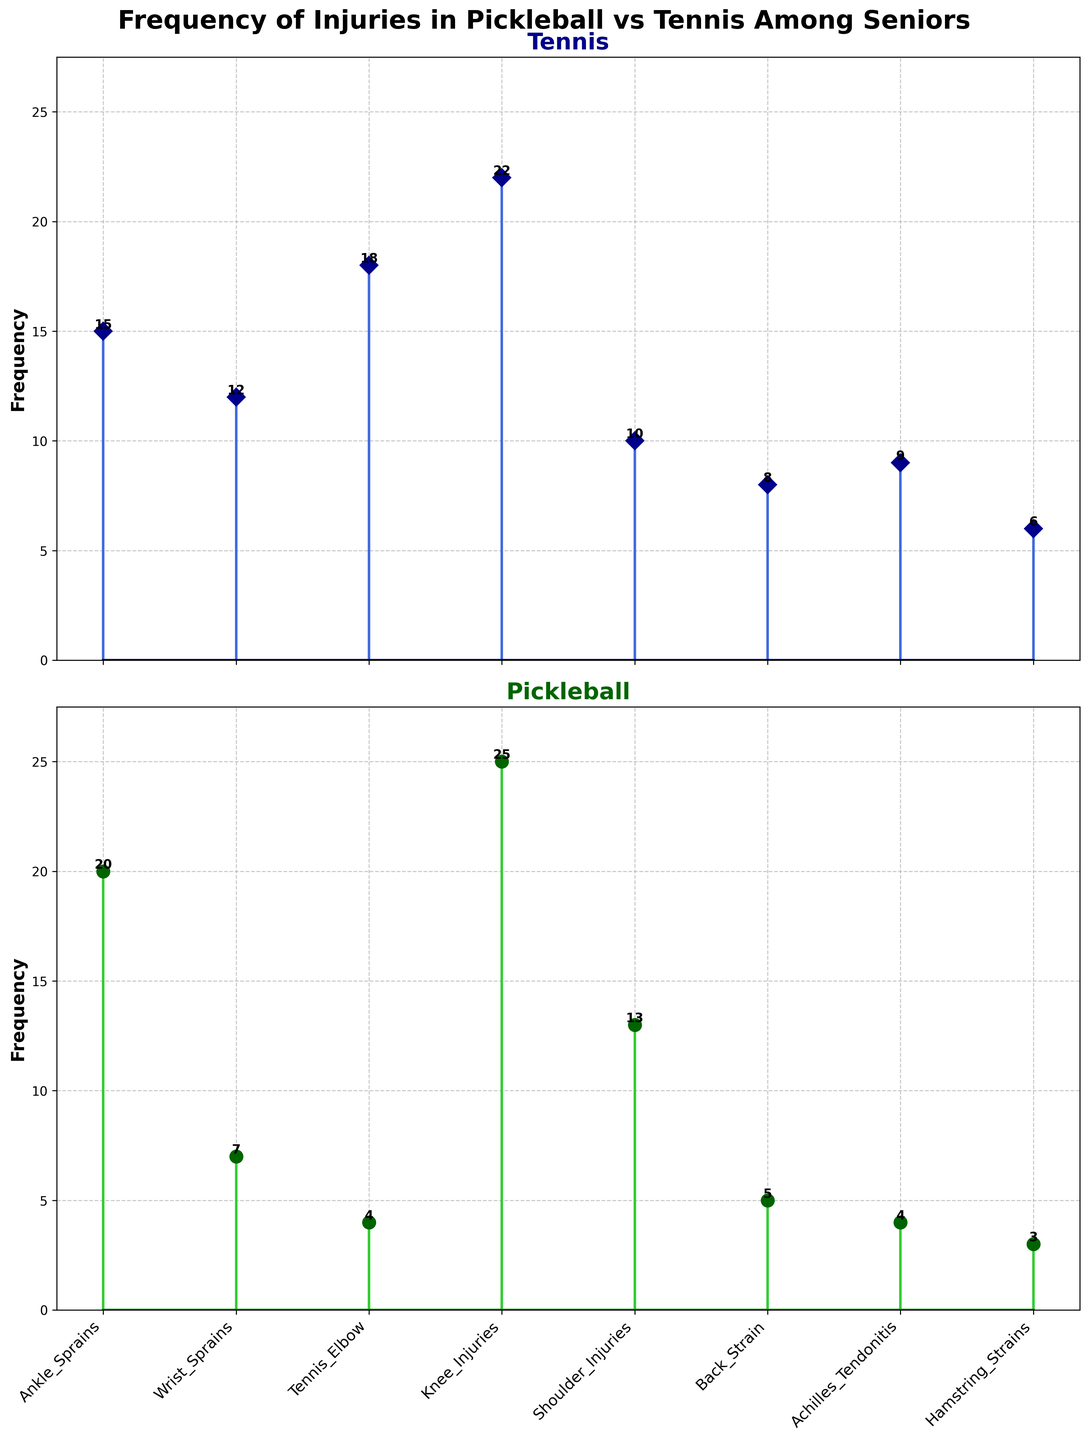What is the title of the top subplot? The title of the top subplot can be seen at the top of the first plot, labeled in bold dark blue. This title should inform the viewer about the specific category or dataset represented by this plot.
Answer: Tennis Which injury type has the highest frequency in pickleball? To identify the injury type with the highest frequency for pickleball, refer to the second subplot (green lines). The stem that extends the furthest upward in this plot indicates the highest frequency.
Answer: Knee_Injuries How many injury types have a higher frequency in pickleball than in tennis? Compare the heights of the corresponding stems in the two plots for all injury types. Count the number of cases where the stem in the pickleball plot (green) is higher than the corresponding stem in the tennis plot (blue).
Answer: 3 What is the average frequency of injuries in tennis? Add the frequencies for all injury types in tennis and divide by the number of injury types. The formula is (15 + 12 + 18 + 22 + 10 + 8 + 9 + 6) / 8.
Answer: 12.5 Which injury type has the greatest difference in frequency between tennis and pickleball? Calculate the absolute difference in frequencies for each injury type by subtracting the pickleball frequency from the tennis frequency. The largest difference indicates the highest disparity.
Answer: Tennis_Elbow What are the total frequencies of all injuries in pickleball? Sum the frequencies of all injury types in pickleball to get the total. The formula is 20 + 7 + 4 + 25 + 13 + 5 + 4 + 3.
Answer: 81 How does the frequency of shoulder injuries in tennis compare to that in pickleball? Observe the stems representing shoulder injuries in both plots. Compare their heights to determine which is greater and by how much.
Answer: Tennis < Pickleball Which injury type has the smallest frequency in both tennis and pickleball? Look for the stems with the shortest height in both subplots for tennis and pickleball. These represent the lowest frequencies.
Answer: Hamstring_Strains Are ankle sprains more common in pickleball or tennis? Compare the height of the stem for ankle sprains in both the tennis and pickleball plots. The taller stem indicates the more common sport for this injury.
Answer: Pickleball How many injury types have an equal frequency in both sports? Compare the heights of the corresponding stems for each injury type in both plots and count the instances where the heights are equal.
Answer: 0 